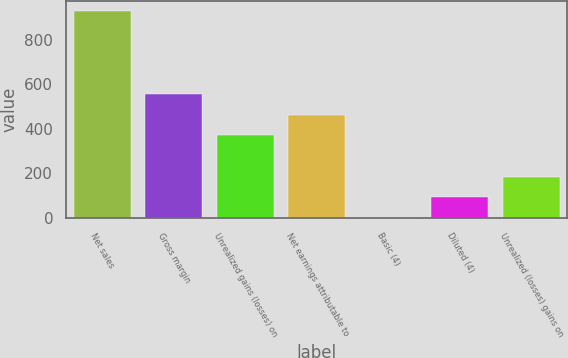Convert chart. <chart><loc_0><loc_0><loc_500><loc_500><bar_chart><fcel>Net sales<fcel>Gross margin<fcel>Unrealized gains (losses) on<fcel>Net earnings attributable to<fcel>Basic (4)<fcel>Diluted (4)<fcel>Unrealized (losses) gains on<nl><fcel>927.4<fcel>556.59<fcel>371.19<fcel>463.89<fcel>0.39<fcel>93.09<fcel>185.79<nl></chart> 